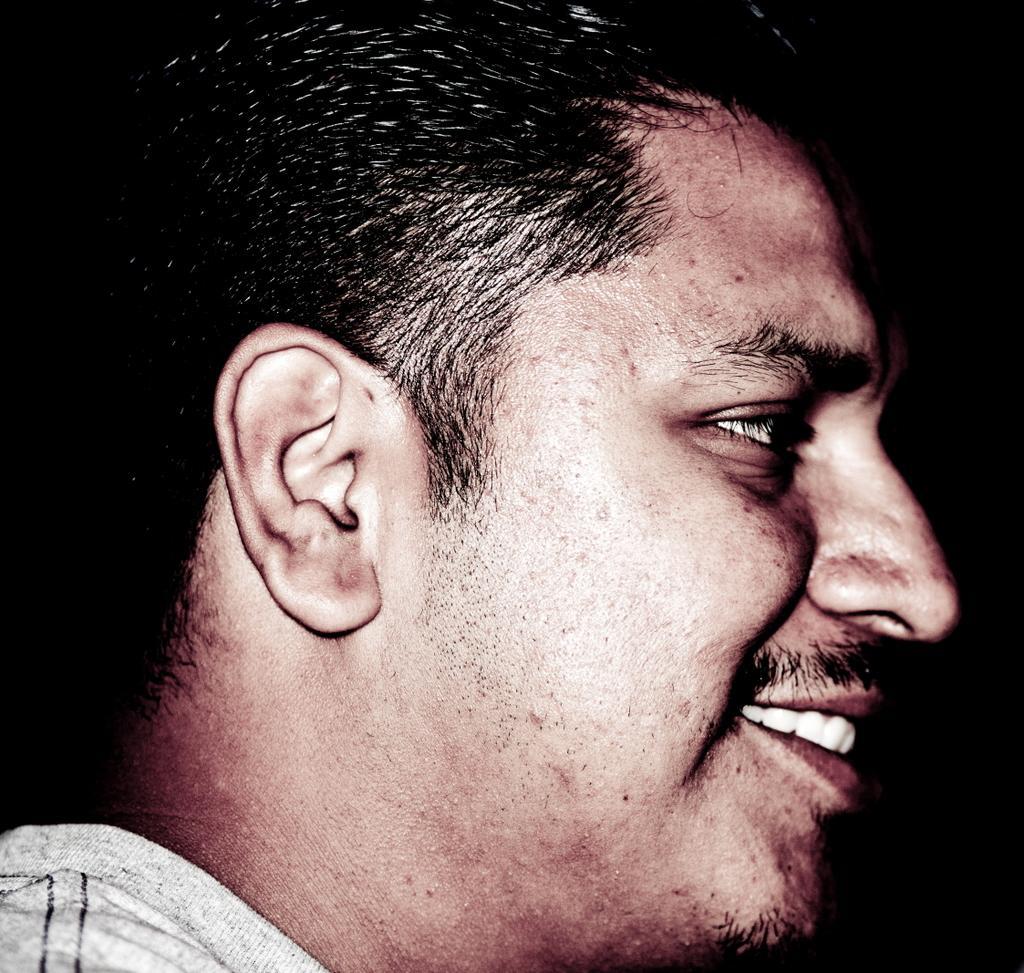In one or two sentences, can you explain what this image depicts? In this picture we can see a man smiling. Background is black in color. 